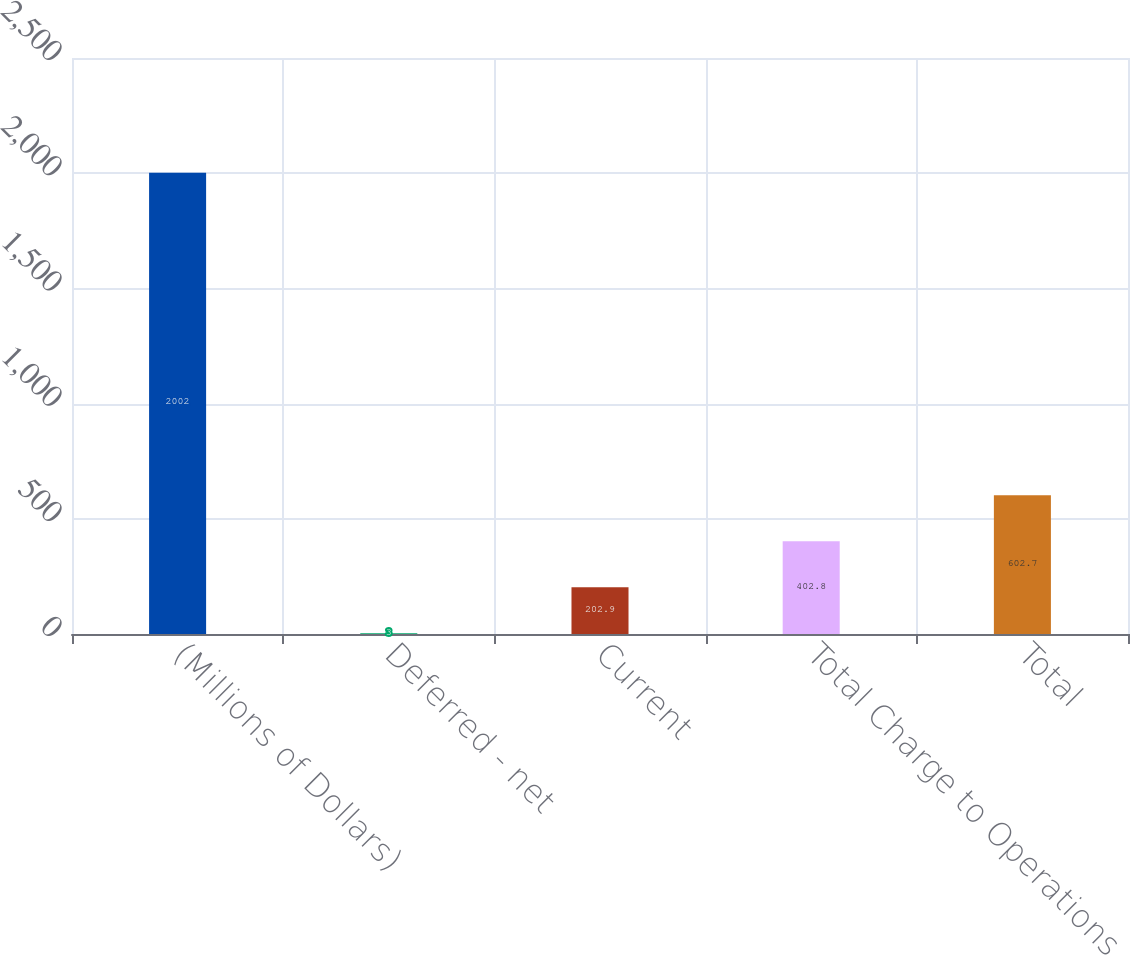Convert chart to OTSL. <chart><loc_0><loc_0><loc_500><loc_500><bar_chart><fcel>(Millions of Dollars)<fcel>Deferred - net<fcel>Current<fcel>Total Charge to Operations<fcel>Total<nl><fcel>2002<fcel>3<fcel>202.9<fcel>402.8<fcel>602.7<nl></chart> 